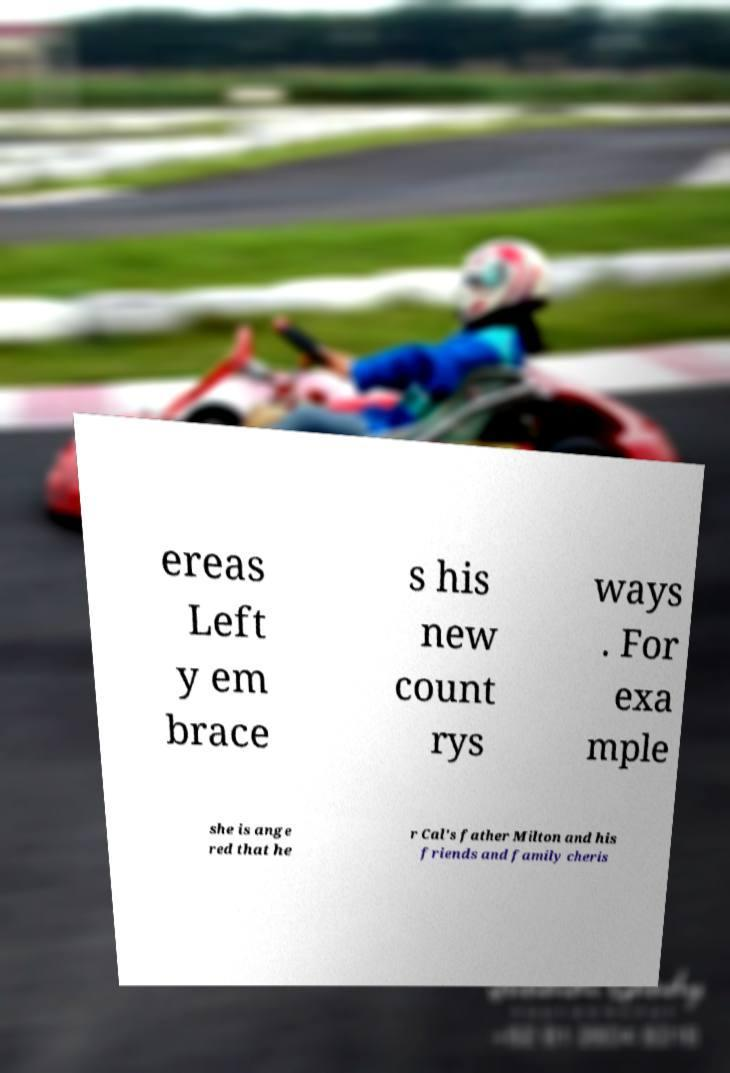There's text embedded in this image that I need extracted. Can you transcribe it verbatim? ereas Left y em brace s his new count rys ways . For exa mple she is ange red that he r Cal's father Milton and his friends and family cheris 